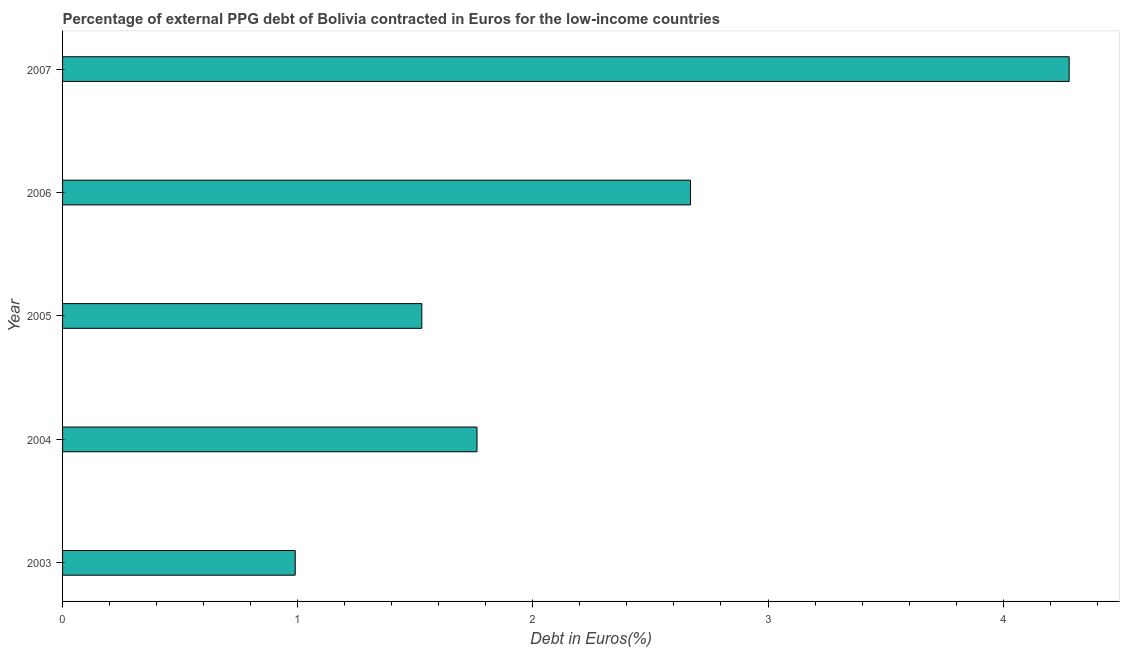Does the graph contain any zero values?
Your answer should be very brief. No. What is the title of the graph?
Offer a terse response. Percentage of external PPG debt of Bolivia contracted in Euros for the low-income countries. What is the label or title of the X-axis?
Ensure brevity in your answer.  Debt in Euros(%). What is the currency composition of ppg debt in 2005?
Keep it short and to the point. 1.53. Across all years, what is the maximum currency composition of ppg debt?
Give a very brief answer. 4.28. In which year was the currency composition of ppg debt maximum?
Make the answer very short. 2007. What is the sum of the currency composition of ppg debt?
Your response must be concise. 11.23. What is the difference between the currency composition of ppg debt in 2005 and 2007?
Give a very brief answer. -2.75. What is the average currency composition of ppg debt per year?
Ensure brevity in your answer.  2.25. What is the median currency composition of ppg debt?
Offer a very short reply. 1.76. Do a majority of the years between 2007 and 2004 (inclusive) have currency composition of ppg debt greater than 1 %?
Provide a succinct answer. Yes. What is the ratio of the currency composition of ppg debt in 2006 to that in 2007?
Give a very brief answer. 0.62. What is the difference between the highest and the second highest currency composition of ppg debt?
Your answer should be compact. 1.61. Is the sum of the currency composition of ppg debt in 2004 and 2006 greater than the maximum currency composition of ppg debt across all years?
Offer a very short reply. Yes. What is the difference between the highest and the lowest currency composition of ppg debt?
Give a very brief answer. 3.29. How many bars are there?
Offer a terse response. 5. Are the values on the major ticks of X-axis written in scientific E-notation?
Provide a short and direct response. No. What is the Debt in Euros(%) of 2004?
Ensure brevity in your answer.  1.76. What is the Debt in Euros(%) in 2005?
Your answer should be very brief. 1.53. What is the Debt in Euros(%) in 2006?
Make the answer very short. 2.67. What is the Debt in Euros(%) in 2007?
Offer a terse response. 4.28. What is the difference between the Debt in Euros(%) in 2003 and 2004?
Your response must be concise. -0.77. What is the difference between the Debt in Euros(%) in 2003 and 2005?
Your answer should be very brief. -0.54. What is the difference between the Debt in Euros(%) in 2003 and 2006?
Provide a succinct answer. -1.68. What is the difference between the Debt in Euros(%) in 2003 and 2007?
Offer a very short reply. -3.29. What is the difference between the Debt in Euros(%) in 2004 and 2005?
Provide a short and direct response. 0.23. What is the difference between the Debt in Euros(%) in 2004 and 2006?
Your answer should be very brief. -0.91. What is the difference between the Debt in Euros(%) in 2004 and 2007?
Offer a very short reply. -2.52. What is the difference between the Debt in Euros(%) in 2005 and 2006?
Provide a short and direct response. -1.14. What is the difference between the Debt in Euros(%) in 2005 and 2007?
Ensure brevity in your answer.  -2.75. What is the difference between the Debt in Euros(%) in 2006 and 2007?
Ensure brevity in your answer.  -1.61. What is the ratio of the Debt in Euros(%) in 2003 to that in 2004?
Keep it short and to the point. 0.56. What is the ratio of the Debt in Euros(%) in 2003 to that in 2005?
Offer a terse response. 0.65. What is the ratio of the Debt in Euros(%) in 2003 to that in 2006?
Ensure brevity in your answer.  0.37. What is the ratio of the Debt in Euros(%) in 2003 to that in 2007?
Your answer should be very brief. 0.23. What is the ratio of the Debt in Euros(%) in 2004 to that in 2005?
Your response must be concise. 1.15. What is the ratio of the Debt in Euros(%) in 2004 to that in 2006?
Provide a succinct answer. 0.66. What is the ratio of the Debt in Euros(%) in 2004 to that in 2007?
Ensure brevity in your answer.  0.41. What is the ratio of the Debt in Euros(%) in 2005 to that in 2006?
Your answer should be very brief. 0.57. What is the ratio of the Debt in Euros(%) in 2005 to that in 2007?
Give a very brief answer. 0.36. What is the ratio of the Debt in Euros(%) in 2006 to that in 2007?
Ensure brevity in your answer.  0.62. 